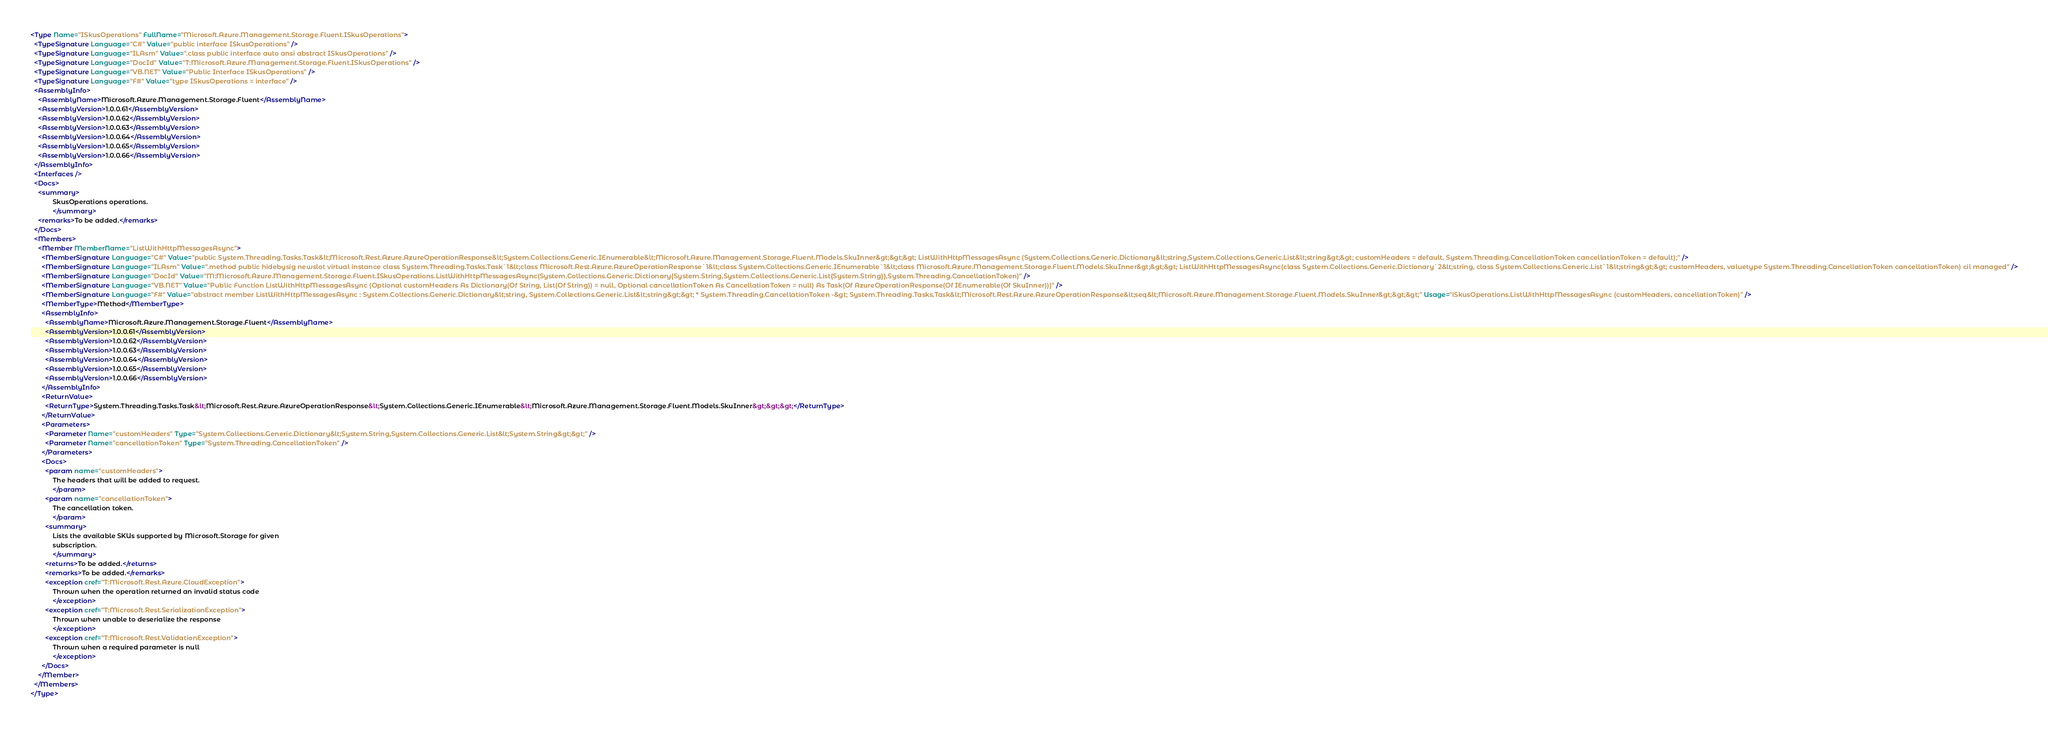Convert code to text. <code><loc_0><loc_0><loc_500><loc_500><_XML_><Type Name="ISkusOperations" FullName="Microsoft.Azure.Management.Storage.Fluent.ISkusOperations">
  <TypeSignature Language="C#" Value="public interface ISkusOperations" />
  <TypeSignature Language="ILAsm" Value=".class public interface auto ansi abstract ISkusOperations" />
  <TypeSignature Language="DocId" Value="T:Microsoft.Azure.Management.Storage.Fluent.ISkusOperations" />
  <TypeSignature Language="VB.NET" Value="Public Interface ISkusOperations" />
  <TypeSignature Language="F#" Value="type ISkusOperations = interface" />
  <AssemblyInfo>
    <AssemblyName>Microsoft.Azure.Management.Storage.Fluent</AssemblyName>
    <AssemblyVersion>1.0.0.61</AssemblyVersion>
    <AssemblyVersion>1.0.0.62</AssemblyVersion>
    <AssemblyVersion>1.0.0.63</AssemblyVersion>
    <AssemblyVersion>1.0.0.64</AssemblyVersion>
    <AssemblyVersion>1.0.0.65</AssemblyVersion>
    <AssemblyVersion>1.0.0.66</AssemblyVersion>
  </AssemblyInfo>
  <Interfaces />
  <Docs>
    <summary>
            SkusOperations operations.
            </summary>
    <remarks>To be added.</remarks>
  </Docs>
  <Members>
    <Member MemberName="ListWithHttpMessagesAsync">
      <MemberSignature Language="C#" Value="public System.Threading.Tasks.Task&lt;Microsoft.Rest.Azure.AzureOperationResponse&lt;System.Collections.Generic.IEnumerable&lt;Microsoft.Azure.Management.Storage.Fluent.Models.SkuInner&gt;&gt;&gt; ListWithHttpMessagesAsync (System.Collections.Generic.Dictionary&lt;string,System.Collections.Generic.List&lt;string&gt;&gt; customHeaders = default, System.Threading.CancellationToken cancellationToken = default);" />
      <MemberSignature Language="ILAsm" Value=".method public hidebysig newslot virtual instance class System.Threading.Tasks.Task`1&lt;class Microsoft.Rest.Azure.AzureOperationResponse`1&lt;class System.Collections.Generic.IEnumerable`1&lt;class Microsoft.Azure.Management.Storage.Fluent.Models.SkuInner&gt;&gt;&gt; ListWithHttpMessagesAsync(class System.Collections.Generic.Dictionary`2&lt;string, class System.Collections.Generic.List`1&lt;string&gt;&gt; customHeaders, valuetype System.Threading.CancellationToken cancellationToken) cil managed" />
      <MemberSignature Language="DocId" Value="M:Microsoft.Azure.Management.Storage.Fluent.ISkusOperations.ListWithHttpMessagesAsync(System.Collections.Generic.Dictionary{System.String,System.Collections.Generic.List{System.String}},System.Threading.CancellationToken)" />
      <MemberSignature Language="VB.NET" Value="Public Function ListWithHttpMessagesAsync (Optional customHeaders As Dictionary(Of String, List(Of String)) = null, Optional cancellationToken As CancellationToken = null) As Task(Of AzureOperationResponse(Of IEnumerable(Of SkuInner)))" />
      <MemberSignature Language="F#" Value="abstract member ListWithHttpMessagesAsync : System.Collections.Generic.Dictionary&lt;string, System.Collections.Generic.List&lt;string&gt;&gt; * System.Threading.CancellationToken -&gt; System.Threading.Tasks.Task&lt;Microsoft.Rest.Azure.AzureOperationResponse&lt;seq&lt;Microsoft.Azure.Management.Storage.Fluent.Models.SkuInner&gt;&gt;&gt;" Usage="iSkusOperations.ListWithHttpMessagesAsync (customHeaders, cancellationToken)" />
      <MemberType>Method</MemberType>
      <AssemblyInfo>
        <AssemblyName>Microsoft.Azure.Management.Storage.Fluent</AssemblyName>
        <AssemblyVersion>1.0.0.61</AssemblyVersion>
        <AssemblyVersion>1.0.0.62</AssemblyVersion>
        <AssemblyVersion>1.0.0.63</AssemblyVersion>
        <AssemblyVersion>1.0.0.64</AssemblyVersion>
        <AssemblyVersion>1.0.0.65</AssemblyVersion>
        <AssemblyVersion>1.0.0.66</AssemblyVersion>
      </AssemblyInfo>
      <ReturnValue>
        <ReturnType>System.Threading.Tasks.Task&lt;Microsoft.Rest.Azure.AzureOperationResponse&lt;System.Collections.Generic.IEnumerable&lt;Microsoft.Azure.Management.Storage.Fluent.Models.SkuInner&gt;&gt;&gt;</ReturnType>
      </ReturnValue>
      <Parameters>
        <Parameter Name="customHeaders" Type="System.Collections.Generic.Dictionary&lt;System.String,System.Collections.Generic.List&lt;System.String&gt;&gt;" />
        <Parameter Name="cancellationToken" Type="System.Threading.CancellationToken" />
      </Parameters>
      <Docs>
        <param name="customHeaders">
            The headers that will be added to request.
            </param>
        <param name="cancellationToken">
            The cancellation token.
            </param>
        <summary>
            Lists the available SKUs supported by Microsoft.Storage for given
            subscription.
            </summary>
        <returns>To be added.</returns>
        <remarks>To be added.</remarks>
        <exception cref="T:Microsoft.Rest.Azure.CloudException">
            Thrown when the operation returned an invalid status code
            </exception>
        <exception cref="T:Microsoft.Rest.SerializationException">
            Thrown when unable to deserialize the response
            </exception>
        <exception cref="T:Microsoft.Rest.ValidationException">
            Thrown when a required parameter is null
            </exception>
      </Docs>
    </Member>
  </Members>
</Type>
</code> 